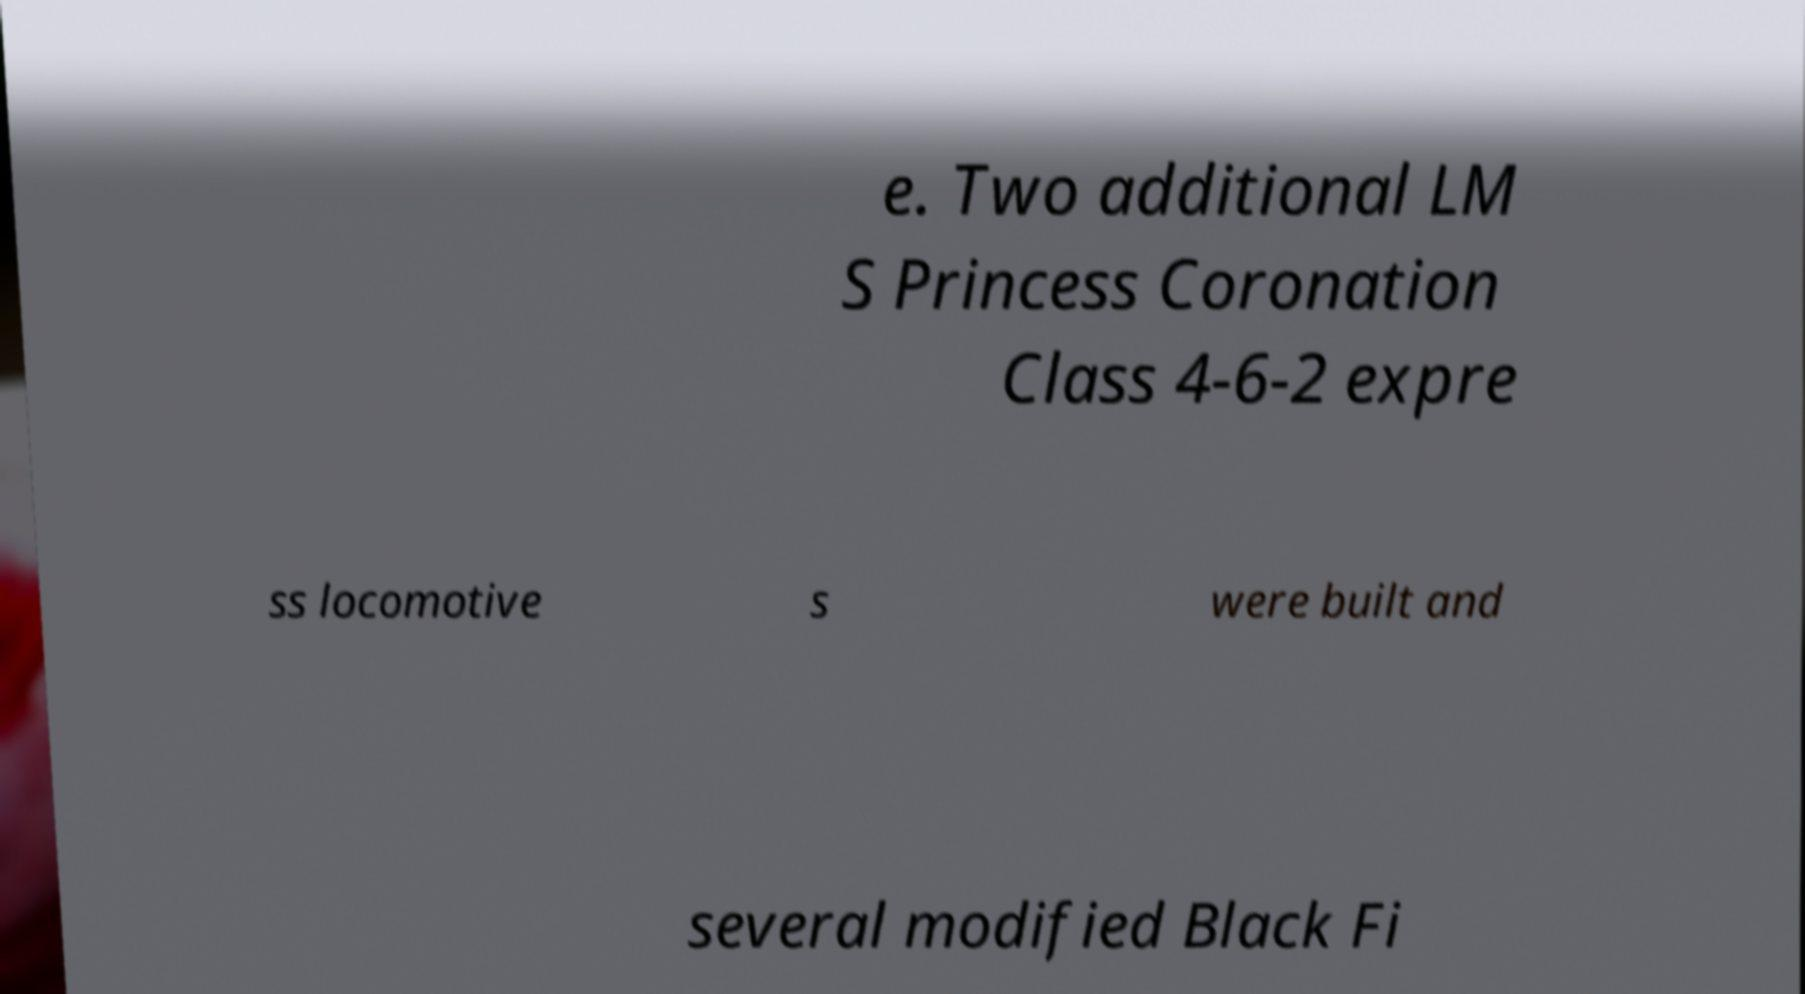Could you assist in decoding the text presented in this image and type it out clearly? e. Two additional LM S Princess Coronation Class 4-6-2 expre ss locomotive s were built and several modified Black Fi 